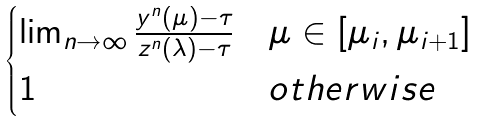Convert formula to latex. <formula><loc_0><loc_0><loc_500><loc_500>\begin{cases} \lim _ { n \to \infty } \frac { y ^ { n } ( \mu ) - \tau } { z ^ { n } ( \lambda ) - \tau } & \mu \in [ \mu _ { i } , \mu _ { i + 1 } ] \\ 1 & o t h e r w i s e \end{cases}</formula> 